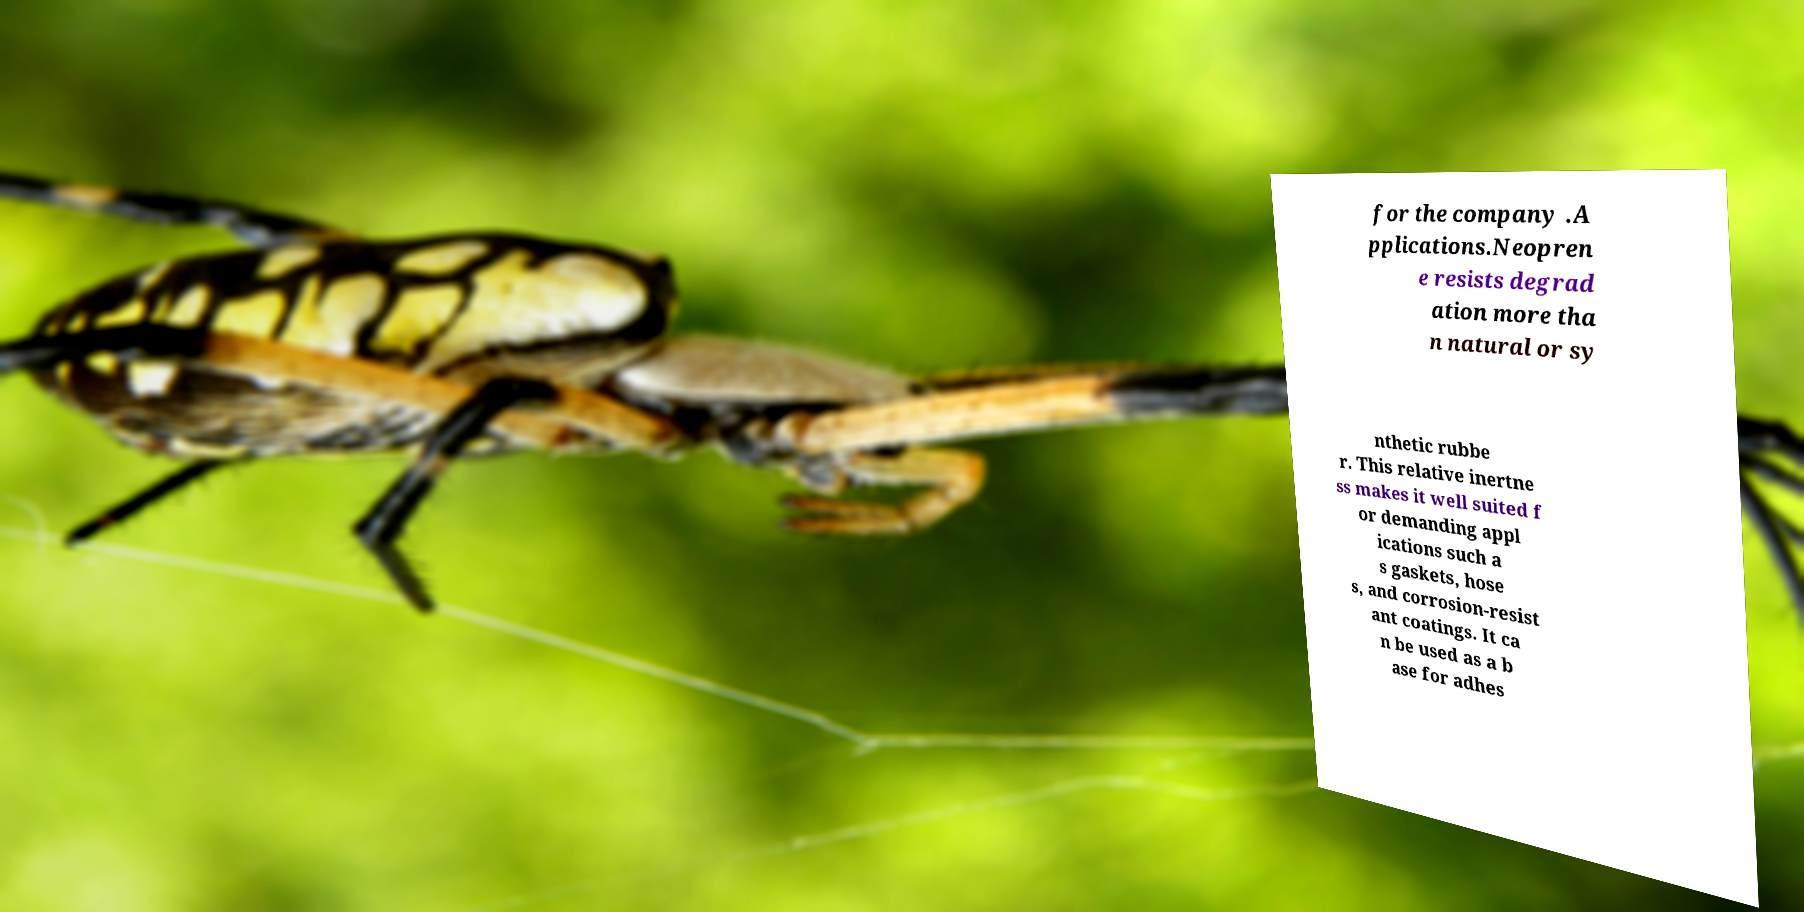Could you extract and type out the text from this image? for the company .A pplications.Neopren e resists degrad ation more tha n natural or sy nthetic rubbe r. This relative inertne ss makes it well suited f or demanding appl ications such a s gaskets, hose s, and corrosion-resist ant coatings. It ca n be used as a b ase for adhes 